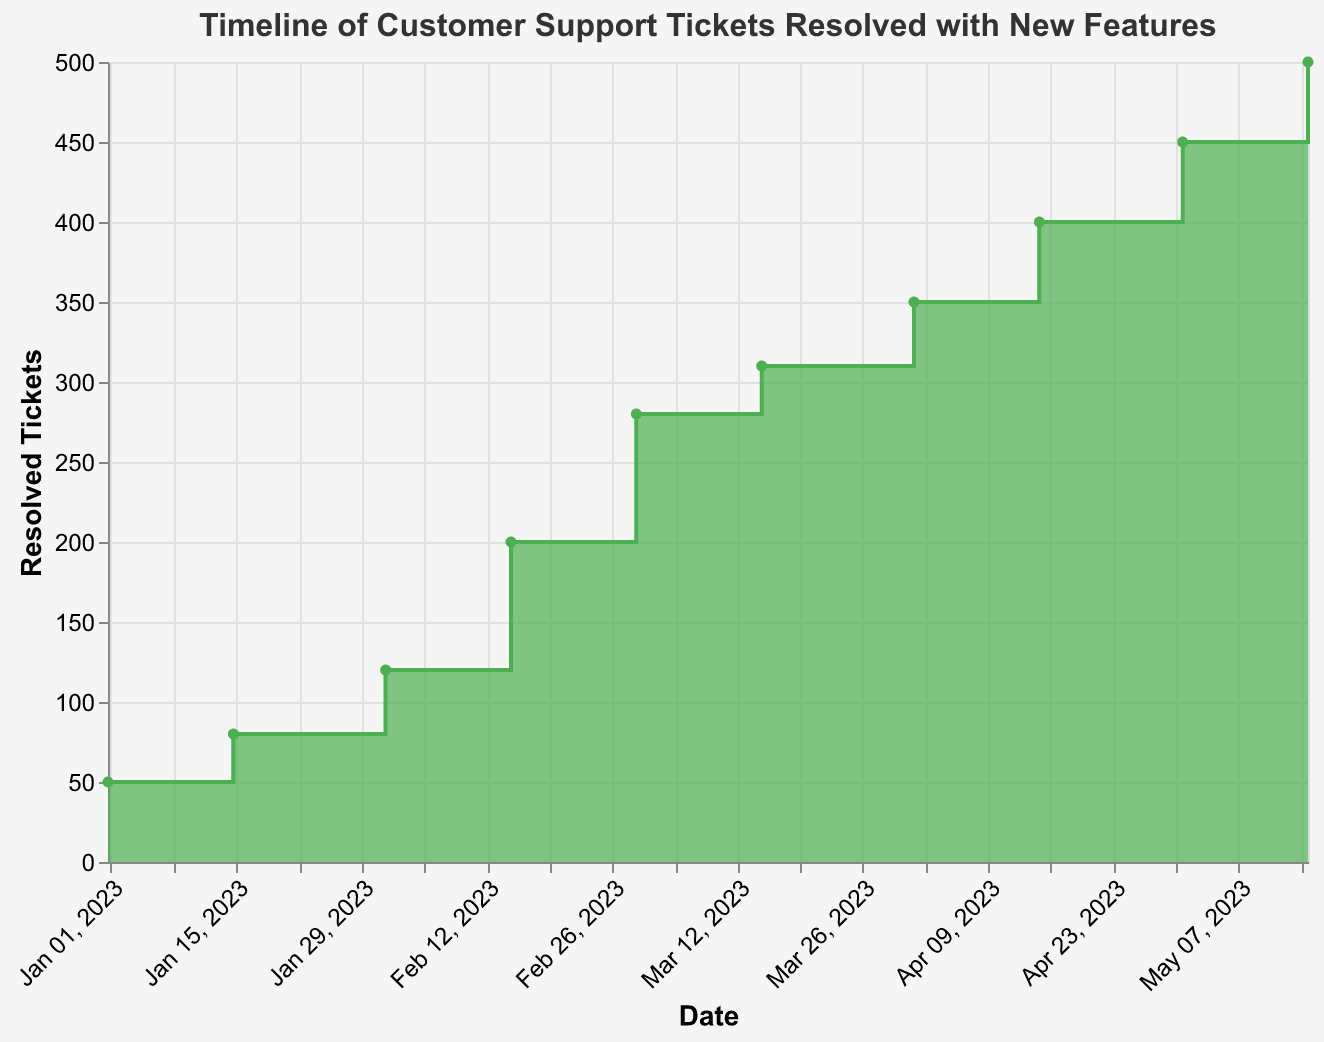What's the title of the chart? The title of the chart is displayed at the top, indicating the main focus of the visualization.
Answer: Timeline of Customer Support Tickets Resolved with New Features How many data points are shown on the chart? By counting the points where the data is marked on the step area chart, we can see there are a total of 10 data points.
Answer: 10 Which feature is associated with the highest number of resolved tickets? By examining the tooltip or the y-axis at the highest point on the chart's line, the feature associated with the highest value is identified. The highest point corresponds to 500 tickets resolved with the "User Feedback System."
Answer: User Feedback System What is the number of resolved tickets on February 15, 2023? Look for the tooltip or the point on the chart that corresponds to February 15, 2023, and check the associated tickets resolved. On February 15, the number of resolved tickets is 200 with "Automated Responses."
Answer: 200 How many tickets were resolved from the Mobile App Features release to the Automated Responses release? Subtract the number of resolved tickets at the Mobile App Features release (on February 1, with 120 tickets) from the Automated Responses release (on February 15, with 200 tickets): 200 - 120 = 80.
Answer: 80 Which two consecutive features show the largest increase in resolved tickets? To identify the largest increase, calculate the difference between the resolved tickets of each pair of consecutive features and find the pair with the maximum difference. The largest increase occurs between "Automated Responses" (200) and "Self-Service Portal" (280), for an increase of 80 tickets.
Answer: Automated Responses and Self-Service Portal What is the average number of resolved tickets from January 1, 2023, to May 15, 2023? Sum up all the resolved tickets and divide by the number of data points: (50 + 80 + 120 + 200 + 280 + 310 + 350 + 400 + 450 + 500) / 10 = 3140 / 10 = 314.
Answer: 314 How does the trend in the number of resolved tickets change over the timeline? By observing the chart, we see that the number of resolved tickets consistently rises with the implementation of new features, indicating an overall upward trend.
Answer: Upward trend What is the difference in resolved tickets between the Self-Service Portal and Advanced Analytics features? Subtract the number of resolved tickets of Self-Service Portal (280) from Advanced Analytics (350): 350 - 280 = 70.
Answer: 70 What color represents the step area in the chart? The color filling the step area is a consistent green hue across all points.
Answer: Green 